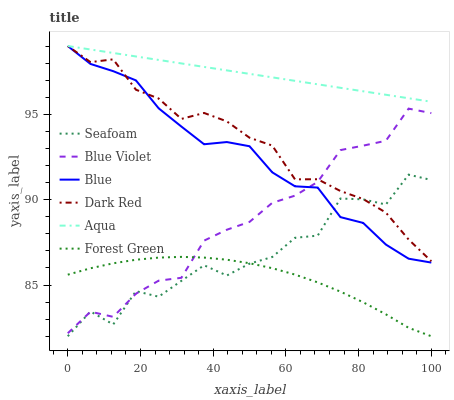Does Forest Green have the minimum area under the curve?
Answer yes or no. Yes. Does Aqua have the maximum area under the curve?
Answer yes or no. Yes. Does Dark Red have the minimum area under the curve?
Answer yes or no. No. Does Dark Red have the maximum area under the curve?
Answer yes or no. No. Is Aqua the smoothest?
Answer yes or no. Yes. Is Seafoam the roughest?
Answer yes or no. Yes. Is Dark Red the smoothest?
Answer yes or no. No. Is Dark Red the roughest?
Answer yes or no. No. Does Seafoam have the lowest value?
Answer yes or no. Yes. Does Dark Red have the lowest value?
Answer yes or no. No. Does Aqua have the highest value?
Answer yes or no. Yes. Does Seafoam have the highest value?
Answer yes or no. No. Is Forest Green less than Aqua?
Answer yes or no. Yes. Is Aqua greater than Seafoam?
Answer yes or no. Yes. Does Blue Violet intersect Forest Green?
Answer yes or no. Yes. Is Blue Violet less than Forest Green?
Answer yes or no. No. Is Blue Violet greater than Forest Green?
Answer yes or no. No. Does Forest Green intersect Aqua?
Answer yes or no. No. 